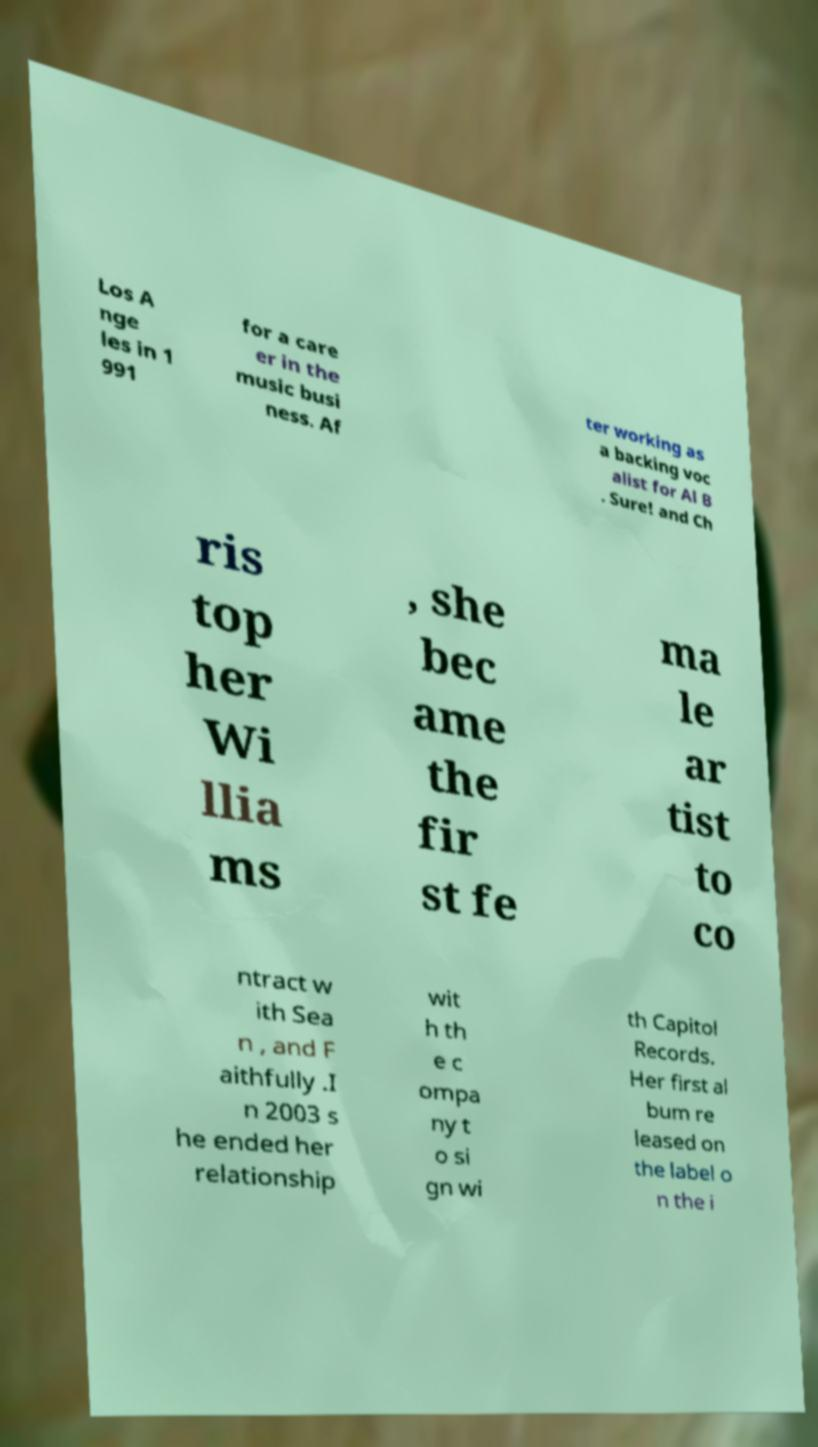Please read and relay the text visible in this image. What does it say? Los A nge les in 1 991 for a care er in the music busi ness. Af ter working as a backing voc alist for Al B . Sure! and Ch ris top her Wi llia ms , she bec ame the fir st fe ma le ar tist to co ntract w ith Sea n , and F aithfully .I n 2003 s he ended her relationship wit h th e c ompa ny t o si gn wi th Capitol Records. Her first al bum re leased on the label o n the i 